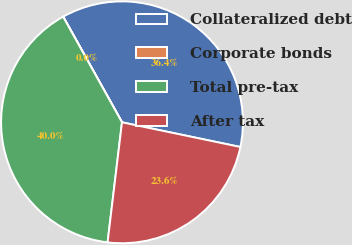<chart> <loc_0><loc_0><loc_500><loc_500><pie_chart><fcel>Collateralized debt<fcel>Corporate bonds<fcel>Total pre-tax<fcel>After tax<nl><fcel>36.36%<fcel>0.01%<fcel>40.0%<fcel>23.63%<nl></chart> 